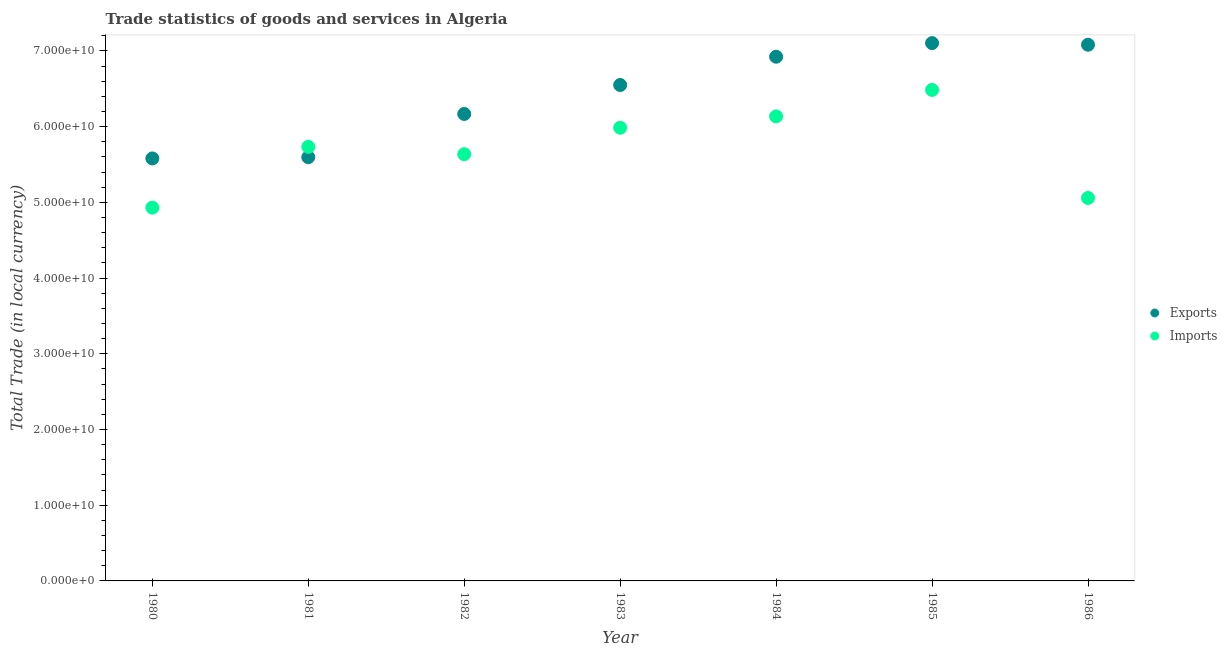How many different coloured dotlines are there?
Offer a very short reply. 2. Is the number of dotlines equal to the number of legend labels?
Offer a very short reply. Yes. What is the imports of goods and services in 1985?
Give a very brief answer. 6.48e+1. Across all years, what is the maximum export of goods and services?
Your answer should be very brief. 7.10e+1. Across all years, what is the minimum imports of goods and services?
Provide a short and direct response. 4.93e+1. In which year was the imports of goods and services minimum?
Your answer should be very brief. 1980. What is the total export of goods and services in the graph?
Your answer should be very brief. 4.50e+11. What is the difference between the export of goods and services in 1981 and that in 1986?
Provide a short and direct response. -1.49e+1. What is the difference between the export of goods and services in 1985 and the imports of goods and services in 1981?
Your answer should be compact. 1.37e+1. What is the average export of goods and services per year?
Keep it short and to the point. 6.43e+1. In the year 1986, what is the difference between the imports of goods and services and export of goods and services?
Make the answer very short. -2.02e+1. In how many years, is the export of goods and services greater than 10000000000 LCU?
Give a very brief answer. 7. What is the ratio of the imports of goods and services in 1982 to that in 1984?
Offer a terse response. 0.92. Is the export of goods and services in 1983 less than that in 1984?
Provide a short and direct response. Yes. Is the difference between the export of goods and services in 1981 and 1984 greater than the difference between the imports of goods and services in 1981 and 1984?
Provide a succinct answer. No. What is the difference between the highest and the second highest export of goods and services?
Keep it short and to the point. 2.13e+08. What is the difference between the highest and the lowest export of goods and services?
Ensure brevity in your answer.  1.52e+1. How many dotlines are there?
Offer a terse response. 2. Does the graph contain any zero values?
Ensure brevity in your answer.  No. Does the graph contain grids?
Ensure brevity in your answer.  No. What is the title of the graph?
Give a very brief answer. Trade statistics of goods and services in Algeria. What is the label or title of the X-axis?
Your response must be concise. Year. What is the label or title of the Y-axis?
Provide a short and direct response. Total Trade (in local currency). What is the Total Trade (in local currency) in Exports in 1980?
Your answer should be very brief. 5.58e+1. What is the Total Trade (in local currency) in Imports in 1980?
Offer a terse response. 4.93e+1. What is the Total Trade (in local currency) of Exports in 1981?
Your answer should be compact. 5.60e+1. What is the Total Trade (in local currency) of Imports in 1981?
Provide a succinct answer. 5.73e+1. What is the Total Trade (in local currency) of Exports in 1982?
Offer a terse response. 6.17e+1. What is the Total Trade (in local currency) in Imports in 1982?
Make the answer very short. 5.64e+1. What is the Total Trade (in local currency) in Exports in 1983?
Your answer should be very brief. 6.55e+1. What is the Total Trade (in local currency) in Imports in 1983?
Offer a terse response. 5.99e+1. What is the Total Trade (in local currency) in Exports in 1984?
Keep it short and to the point. 6.92e+1. What is the Total Trade (in local currency) in Imports in 1984?
Make the answer very short. 6.14e+1. What is the Total Trade (in local currency) of Exports in 1985?
Your response must be concise. 7.10e+1. What is the Total Trade (in local currency) in Imports in 1985?
Your answer should be compact. 6.48e+1. What is the Total Trade (in local currency) of Exports in 1986?
Offer a terse response. 7.08e+1. What is the Total Trade (in local currency) in Imports in 1986?
Provide a succinct answer. 5.06e+1. Across all years, what is the maximum Total Trade (in local currency) of Exports?
Provide a short and direct response. 7.10e+1. Across all years, what is the maximum Total Trade (in local currency) in Imports?
Offer a terse response. 6.48e+1. Across all years, what is the minimum Total Trade (in local currency) of Exports?
Make the answer very short. 5.58e+1. Across all years, what is the minimum Total Trade (in local currency) of Imports?
Provide a short and direct response. 4.93e+1. What is the total Total Trade (in local currency) in Exports in the graph?
Ensure brevity in your answer.  4.50e+11. What is the total Total Trade (in local currency) of Imports in the graph?
Your response must be concise. 4.00e+11. What is the difference between the Total Trade (in local currency) in Exports in 1980 and that in 1981?
Keep it short and to the point. -1.67e+08. What is the difference between the Total Trade (in local currency) of Imports in 1980 and that in 1981?
Keep it short and to the point. -8.04e+09. What is the difference between the Total Trade (in local currency) of Exports in 1980 and that in 1982?
Your response must be concise. -5.88e+09. What is the difference between the Total Trade (in local currency) of Imports in 1980 and that in 1982?
Give a very brief answer. -7.06e+09. What is the difference between the Total Trade (in local currency) in Exports in 1980 and that in 1983?
Ensure brevity in your answer.  -9.70e+09. What is the difference between the Total Trade (in local currency) in Imports in 1980 and that in 1983?
Provide a succinct answer. -1.06e+1. What is the difference between the Total Trade (in local currency) of Exports in 1980 and that in 1984?
Your answer should be compact. -1.34e+1. What is the difference between the Total Trade (in local currency) of Imports in 1980 and that in 1984?
Your answer should be very brief. -1.21e+1. What is the difference between the Total Trade (in local currency) of Exports in 1980 and that in 1985?
Provide a succinct answer. -1.52e+1. What is the difference between the Total Trade (in local currency) of Imports in 1980 and that in 1985?
Ensure brevity in your answer.  -1.55e+1. What is the difference between the Total Trade (in local currency) of Exports in 1980 and that in 1986?
Provide a short and direct response. -1.50e+1. What is the difference between the Total Trade (in local currency) in Imports in 1980 and that in 1986?
Your answer should be compact. -1.28e+09. What is the difference between the Total Trade (in local currency) of Exports in 1981 and that in 1982?
Provide a succinct answer. -5.71e+09. What is the difference between the Total Trade (in local currency) of Imports in 1981 and that in 1982?
Provide a succinct answer. 9.75e+08. What is the difference between the Total Trade (in local currency) in Exports in 1981 and that in 1983?
Your response must be concise. -9.53e+09. What is the difference between the Total Trade (in local currency) of Imports in 1981 and that in 1983?
Provide a succinct answer. -2.52e+09. What is the difference between the Total Trade (in local currency) in Exports in 1981 and that in 1984?
Your answer should be very brief. -1.33e+1. What is the difference between the Total Trade (in local currency) of Imports in 1981 and that in 1984?
Provide a short and direct response. -4.02e+09. What is the difference between the Total Trade (in local currency) of Exports in 1981 and that in 1985?
Provide a succinct answer. -1.51e+1. What is the difference between the Total Trade (in local currency) of Imports in 1981 and that in 1985?
Give a very brief answer. -7.51e+09. What is the difference between the Total Trade (in local currency) in Exports in 1981 and that in 1986?
Your answer should be compact. -1.49e+1. What is the difference between the Total Trade (in local currency) of Imports in 1981 and that in 1986?
Provide a short and direct response. 6.75e+09. What is the difference between the Total Trade (in local currency) of Exports in 1982 and that in 1983?
Your answer should be very brief. -3.82e+09. What is the difference between the Total Trade (in local currency) in Imports in 1982 and that in 1983?
Your answer should be very brief. -3.49e+09. What is the difference between the Total Trade (in local currency) in Exports in 1982 and that in 1984?
Your answer should be very brief. -7.56e+09. What is the difference between the Total Trade (in local currency) of Imports in 1982 and that in 1984?
Make the answer very short. -4.99e+09. What is the difference between the Total Trade (in local currency) of Exports in 1982 and that in 1985?
Give a very brief answer. -9.36e+09. What is the difference between the Total Trade (in local currency) of Imports in 1982 and that in 1985?
Provide a short and direct response. -8.49e+09. What is the difference between the Total Trade (in local currency) in Exports in 1982 and that in 1986?
Give a very brief answer. -9.14e+09. What is the difference between the Total Trade (in local currency) in Imports in 1982 and that in 1986?
Keep it short and to the point. 5.78e+09. What is the difference between the Total Trade (in local currency) in Exports in 1983 and that in 1984?
Offer a terse response. -3.73e+09. What is the difference between the Total Trade (in local currency) of Imports in 1983 and that in 1984?
Offer a very short reply. -1.50e+09. What is the difference between the Total Trade (in local currency) of Exports in 1983 and that in 1985?
Your answer should be compact. -5.53e+09. What is the difference between the Total Trade (in local currency) in Imports in 1983 and that in 1985?
Provide a succinct answer. -4.99e+09. What is the difference between the Total Trade (in local currency) in Exports in 1983 and that in 1986?
Provide a succinct answer. -5.32e+09. What is the difference between the Total Trade (in local currency) of Imports in 1983 and that in 1986?
Ensure brevity in your answer.  9.27e+09. What is the difference between the Total Trade (in local currency) in Exports in 1984 and that in 1985?
Keep it short and to the point. -1.80e+09. What is the difference between the Total Trade (in local currency) of Imports in 1984 and that in 1985?
Make the answer very short. -3.50e+09. What is the difference between the Total Trade (in local currency) in Exports in 1984 and that in 1986?
Your response must be concise. -1.59e+09. What is the difference between the Total Trade (in local currency) in Imports in 1984 and that in 1986?
Give a very brief answer. 1.08e+1. What is the difference between the Total Trade (in local currency) of Exports in 1985 and that in 1986?
Your answer should be compact. 2.13e+08. What is the difference between the Total Trade (in local currency) of Imports in 1985 and that in 1986?
Offer a terse response. 1.43e+1. What is the difference between the Total Trade (in local currency) in Exports in 1980 and the Total Trade (in local currency) in Imports in 1981?
Your answer should be compact. -1.54e+09. What is the difference between the Total Trade (in local currency) of Exports in 1980 and the Total Trade (in local currency) of Imports in 1982?
Give a very brief answer. -5.61e+08. What is the difference between the Total Trade (in local currency) of Exports in 1980 and the Total Trade (in local currency) of Imports in 1983?
Make the answer very short. -4.06e+09. What is the difference between the Total Trade (in local currency) of Exports in 1980 and the Total Trade (in local currency) of Imports in 1984?
Offer a terse response. -5.55e+09. What is the difference between the Total Trade (in local currency) in Exports in 1980 and the Total Trade (in local currency) in Imports in 1985?
Provide a succinct answer. -9.05e+09. What is the difference between the Total Trade (in local currency) in Exports in 1980 and the Total Trade (in local currency) in Imports in 1986?
Provide a succinct answer. 5.22e+09. What is the difference between the Total Trade (in local currency) in Exports in 1981 and the Total Trade (in local currency) in Imports in 1982?
Your answer should be compact. -3.94e+08. What is the difference between the Total Trade (in local currency) in Exports in 1981 and the Total Trade (in local currency) in Imports in 1983?
Make the answer very short. -3.89e+09. What is the difference between the Total Trade (in local currency) of Exports in 1981 and the Total Trade (in local currency) of Imports in 1984?
Make the answer very short. -5.38e+09. What is the difference between the Total Trade (in local currency) in Exports in 1981 and the Total Trade (in local currency) in Imports in 1985?
Make the answer very short. -8.88e+09. What is the difference between the Total Trade (in local currency) of Exports in 1981 and the Total Trade (in local currency) of Imports in 1986?
Provide a succinct answer. 5.39e+09. What is the difference between the Total Trade (in local currency) of Exports in 1982 and the Total Trade (in local currency) of Imports in 1983?
Keep it short and to the point. 1.82e+09. What is the difference between the Total Trade (in local currency) in Exports in 1982 and the Total Trade (in local currency) in Imports in 1984?
Your answer should be compact. 3.24e+08. What is the difference between the Total Trade (in local currency) of Exports in 1982 and the Total Trade (in local currency) of Imports in 1985?
Keep it short and to the point. -3.17e+09. What is the difference between the Total Trade (in local currency) in Exports in 1982 and the Total Trade (in local currency) in Imports in 1986?
Ensure brevity in your answer.  1.11e+1. What is the difference between the Total Trade (in local currency) in Exports in 1983 and the Total Trade (in local currency) in Imports in 1984?
Keep it short and to the point. 4.15e+09. What is the difference between the Total Trade (in local currency) in Exports in 1983 and the Total Trade (in local currency) in Imports in 1985?
Offer a very short reply. 6.51e+08. What is the difference between the Total Trade (in local currency) in Exports in 1983 and the Total Trade (in local currency) in Imports in 1986?
Offer a terse response. 1.49e+1. What is the difference between the Total Trade (in local currency) in Exports in 1984 and the Total Trade (in local currency) in Imports in 1985?
Keep it short and to the point. 4.38e+09. What is the difference between the Total Trade (in local currency) of Exports in 1984 and the Total Trade (in local currency) of Imports in 1986?
Give a very brief answer. 1.87e+1. What is the difference between the Total Trade (in local currency) of Exports in 1985 and the Total Trade (in local currency) of Imports in 1986?
Offer a very short reply. 2.05e+1. What is the average Total Trade (in local currency) in Exports per year?
Your answer should be compact. 6.43e+1. What is the average Total Trade (in local currency) in Imports per year?
Your answer should be compact. 5.71e+1. In the year 1980, what is the difference between the Total Trade (in local currency) of Exports and Total Trade (in local currency) of Imports?
Provide a succinct answer. 6.50e+09. In the year 1981, what is the difference between the Total Trade (in local currency) of Exports and Total Trade (in local currency) of Imports?
Offer a terse response. -1.37e+09. In the year 1982, what is the difference between the Total Trade (in local currency) in Exports and Total Trade (in local currency) in Imports?
Offer a very short reply. 5.31e+09. In the year 1983, what is the difference between the Total Trade (in local currency) of Exports and Total Trade (in local currency) of Imports?
Your response must be concise. 5.64e+09. In the year 1984, what is the difference between the Total Trade (in local currency) of Exports and Total Trade (in local currency) of Imports?
Your response must be concise. 7.88e+09. In the year 1985, what is the difference between the Total Trade (in local currency) in Exports and Total Trade (in local currency) in Imports?
Give a very brief answer. 6.18e+09. In the year 1986, what is the difference between the Total Trade (in local currency) in Exports and Total Trade (in local currency) in Imports?
Provide a succinct answer. 2.02e+1. What is the ratio of the Total Trade (in local currency) in Imports in 1980 to that in 1981?
Your response must be concise. 0.86. What is the ratio of the Total Trade (in local currency) in Exports in 1980 to that in 1982?
Offer a very short reply. 0.9. What is the ratio of the Total Trade (in local currency) of Imports in 1980 to that in 1982?
Provide a succinct answer. 0.87. What is the ratio of the Total Trade (in local currency) of Exports in 1980 to that in 1983?
Provide a short and direct response. 0.85. What is the ratio of the Total Trade (in local currency) of Imports in 1980 to that in 1983?
Your response must be concise. 0.82. What is the ratio of the Total Trade (in local currency) of Exports in 1980 to that in 1984?
Offer a very short reply. 0.81. What is the ratio of the Total Trade (in local currency) in Imports in 1980 to that in 1984?
Your response must be concise. 0.8. What is the ratio of the Total Trade (in local currency) of Exports in 1980 to that in 1985?
Ensure brevity in your answer.  0.79. What is the ratio of the Total Trade (in local currency) in Imports in 1980 to that in 1985?
Your answer should be compact. 0.76. What is the ratio of the Total Trade (in local currency) of Exports in 1980 to that in 1986?
Provide a succinct answer. 0.79. What is the ratio of the Total Trade (in local currency) of Imports in 1980 to that in 1986?
Ensure brevity in your answer.  0.97. What is the ratio of the Total Trade (in local currency) in Exports in 1981 to that in 1982?
Give a very brief answer. 0.91. What is the ratio of the Total Trade (in local currency) in Imports in 1981 to that in 1982?
Offer a very short reply. 1.02. What is the ratio of the Total Trade (in local currency) in Exports in 1981 to that in 1983?
Make the answer very short. 0.85. What is the ratio of the Total Trade (in local currency) of Imports in 1981 to that in 1983?
Ensure brevity in your answer.  0.96. What is the ratio of the Total Trade (in local currency) of Exports in 1981 to that in 1984?
Keep it short and to the point. 0.81. What is the ratio of the Total Trade (in local currency) of Imports in 1981 to that in 1984?
Offer a terse response. 0.93. What is the ratio of the Total Trade (in local currency) of Exports in 1981 to that in 1985?
Give a very brief answer. 0.79. What is the ratio of the Total Trade (in local currency) in Imports in 1981 to that in 1985?
Keep it short and to the point. 0.88. What is the ratio of the Total Trade (in local currency) in Exports in 1981 to that in 1986?
Give a very brief answer. 0.79. What is the ratio of the Total Trade (in local currency) in Imports in 1981 to that in 1986?
Ensure brevity in your answer.  1.13. What is the ratio of the Total Trade (in local currency) of Exports in 1982 to that in 1983?
Provide a succinct answer. 0.94. What is the ratio of the Total Trade (in local currency) in Imports in 1982 to that in 1983?
Give a very brief answer. 0.94. What is the ratio of the Total Trade (in local currency) in Exports in 1982 to that in 1984?
Offer a very short reply. 0.89. What is the ratio of the Total Trade (in local currency) in Imports in 1982 to that in 1984?
Your answer should be compact. 0.92. What is the ratio of the Total Trade (in local currency) in Exports in 1982 to that in 1985?
Your response must be concise. 0.87. What is the ratio of the Total Trade (in local currency) of Imports in 1982 to that in 1985?
Keep it short and to the point. 0.87. What is the ratio of the Total Trade (in local currency) of Exports in 1982 to that in 1986?
Keep it short and to the point. 0.87. What is the ratio of the Total Trade (in local currency) of Imports in 1982 to that in 1986?
Give a very brief answer. 1.11. What is the ratio of the Total Trade (in local currency) of Exports in 1983 to that in 1984?
Keep it short and to the point. 0.95. What is the ratio of the Total Trade (in local currency) of Imports in 1983 to that in 1984?
Keep it short and to the point. 0.98. What is the ratio of the Total Trade (in local currency) of Exports in 1983 to that in 1985?
Give a very brief answer. 0.92. What is the ratio of the Total Trade (in local currency) in Imports in 1983 to that in 1985?
Your answer should be very brief. 0.92. What is the ratio of the Total Trade (in local currency) in Exports in 1983 to that in 1986?
Your response must be concise. 0.92. What is the ratio of the Total Trade (in local currency) in Imports in 1983 to that in 1986?
Ensure brevity in your answer.  1.18. What is the ratio of the Total Trade (in local currency) in Exports in 1984 to that in 1985?
Your response must be concise. 0.97. What is the ratio of the Total Trade (in local currency) of Imports in 1984 to that in 1985?
Offer a terse response. 0.95. What is the ratio of the Total Trade (in local currency) of Exports in 1984 to that in 1986?
Ensure brevity in your answer.  0.98. What is the ratio of the Total Trade (in local currency) in Imports in 1984 to that in 1986?
Offer a terse response. 1.21. What is the ratio of the Total Trade (in local currency) in Imports in 1985 to that in 1986?
Make the answer very short. 1.28. What is the difference between the highest and the second highest Total Trade (in local currency) in Exports?
Your answer should be very brief. 2.13e+08. What is the difference between the highest and the second highest Total Trade (in local currency) in Imports?
Offer a terse response. 3.50e+09. What is the difference between the highest and the lowest Total Trade (in local currency) of Exports?
Give a very brief answer. 1.52e+1. What is the difference between the highest and the lowest Total Trade (in local currency) of Imports?
Provide a succinct answer. 1.55e+1. 